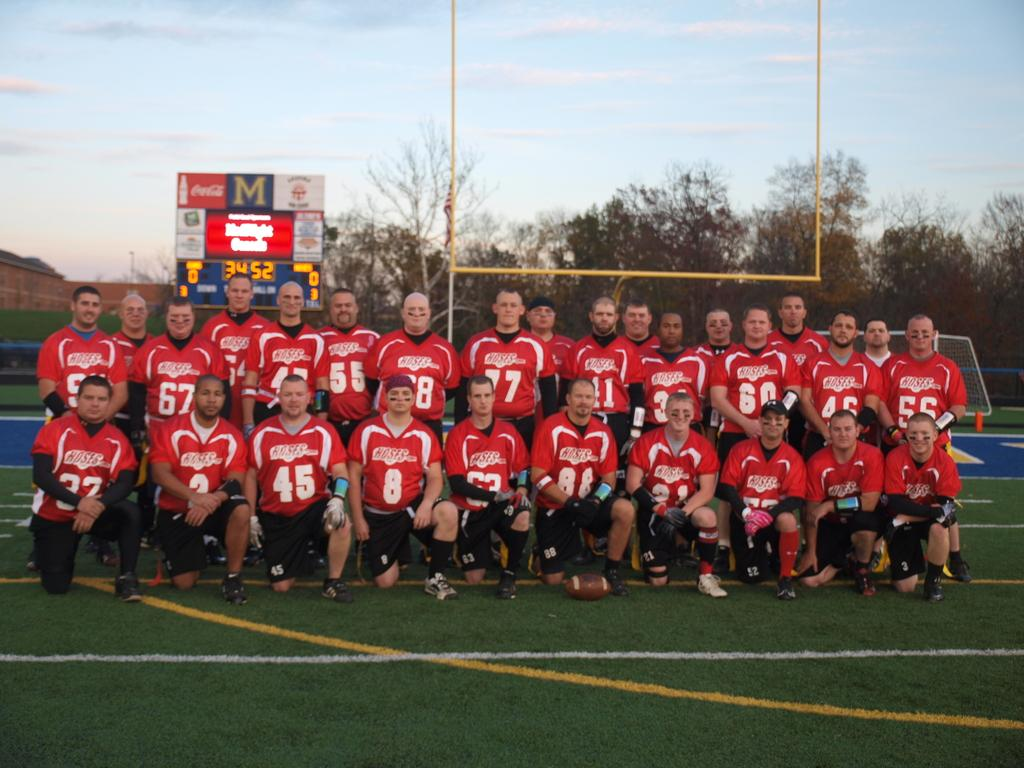<image>
Create a compact narrative representing the image presented. A men's sports team poses for a picture on a field sponsored by Coca-Cola. 